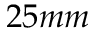Convert formula to latex. <formula><loc_0><loc_0><loc_500><loc_500>2 5 m m</formula> 